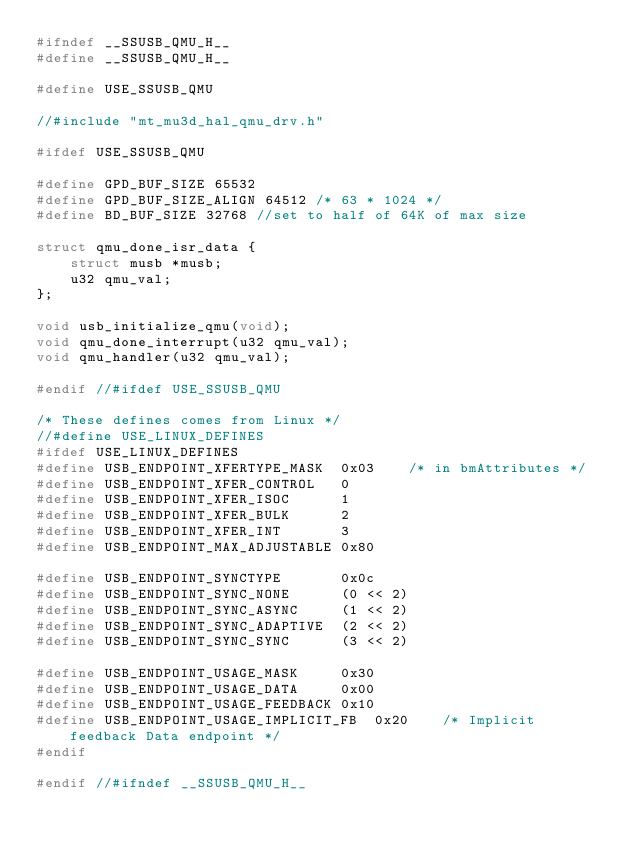Convert code to text. <code><loc_0><loc_0><loc_500><loc_500><_C_>#ifndef __SSUSB_QMU_H__
#define __SSUSB_QMU_H__

#define USE_SSUSB_QMU

//#include "mt_mu3d_hal_qmu_drv.h"

#ifdef USE_SSUSB_QMU

#define GPD_BUF_SIZE 65532
#define GPD_BUF_SIZE_ALIGN 64512 /* 63 * 1024 */
#define BD_BUF_SIZE 32768 //set to half of 64K of max size

struct qmu_done_isr_data {
	struct musb *musb; 
	u32 qmu_val;
};

void usb_initialize_qmu(void);
void qmu_done_interrupt(u32 qmu_val);
void qmu_handler(u32 qmu_val);

#endif //#ifdef USE_SSUSB_QMU

/* These defines comes from Linux */
//#define USE_LINUX_DEFINES
#ifdef USE_LINUX_DEFINES
#define USB_ENDPOINT_XFERTYPE_MASK	0x03	/* in bmAttributes */
#define USB_ENDPOINT_XFER_CONTROL	0
#define USB_ENDPOINT_XFER_ISOC		1
#define USB_ENDPOINT_XFER_BULK		2
#define USB_ENDPOINT_XFER_INT		3
#define USB_ENDPOINT_MAX_ADJUSTABLE	0x80

#define USB_ENDPOINT_SYNCTYPE		0x0c
#define USB_ENDPOINT_SYNC_NONE		(0 << 2)
#define USB_ENDPOINT_SYNC_ASYNC		(1 << 2)
#define USB_ENDPOINT_SYNC_ADAPTIVE	(2 << 2)
#define USB_ENDPOINT_SYNC_SYNC		(3 << 2)

#define USB_ENDPOINT_USAGE_MASK		0x30
#define USB_ENDPOINT_USAGE_DATA		0x00
#define USB_ENDPOINT_USAGE_FEEDBACK	0x10
#define USB_ENDPOINT_USAGE_IMPLICIT_FB	0x20	/* Implicit feedback Data endpoint */
#endif

#endif //#ifndef __SSUSB_QMU_H__
</code> 